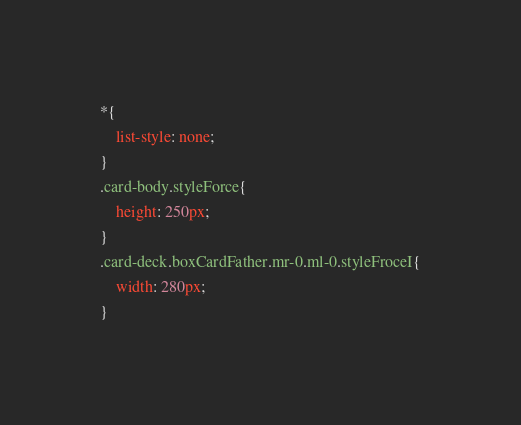Convert code to text. <code><loc_0><loc_0><loc_500><loc_500><_CSS_>*{
    list-style: none;
}
.card-body.styleForce{
    height: 250px;
}
.card-deck.boxCardFather.mr-0.ml-0.styleFroceI{
    width: 280px;
}
</code> 